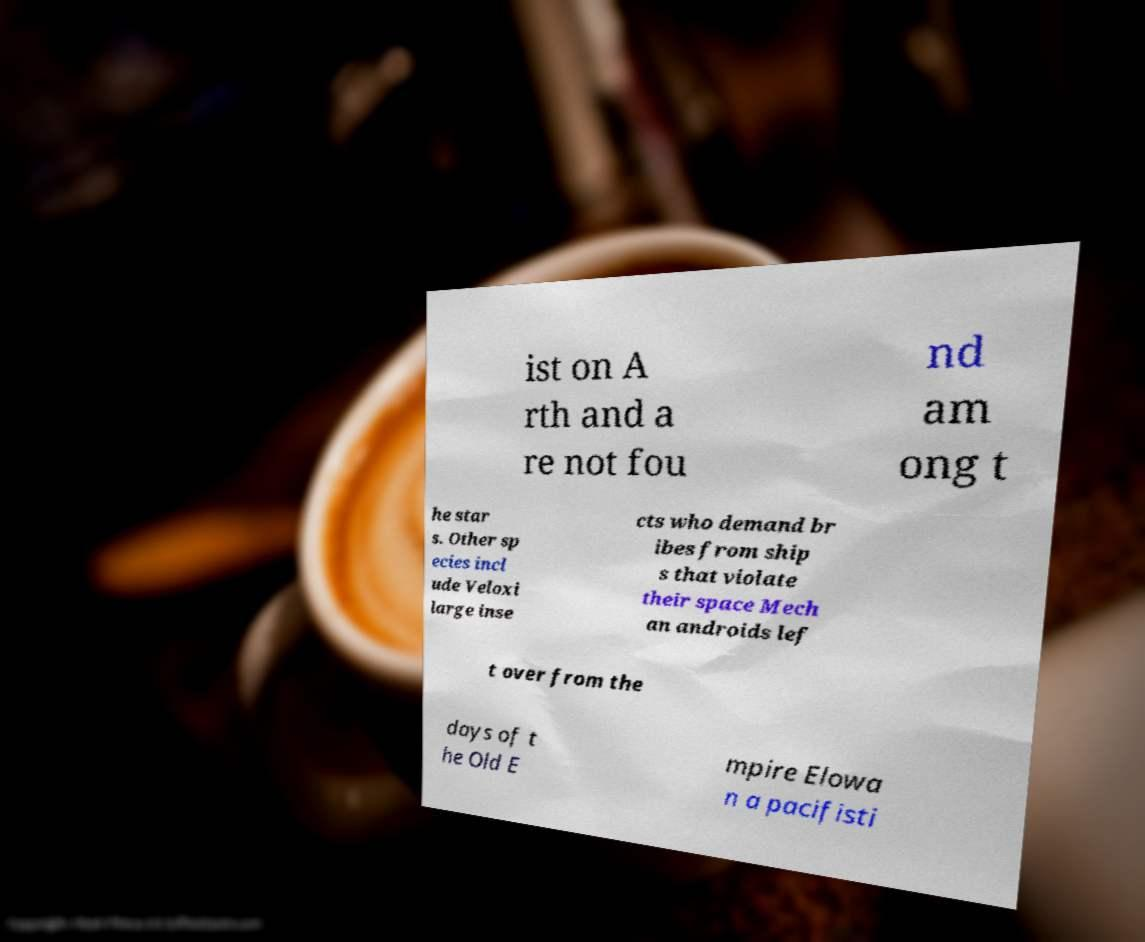I need the written content from this picture converted into text. Can you do that? ist on A rth and a re not fou nd am ong t he star s. Other sp ecies incl ude Veloxi large inse cts who demand br ibes from ship s that violate their space Mech an androids lef t over from the days of t he Old E mpire Elowa n a pacifisti 